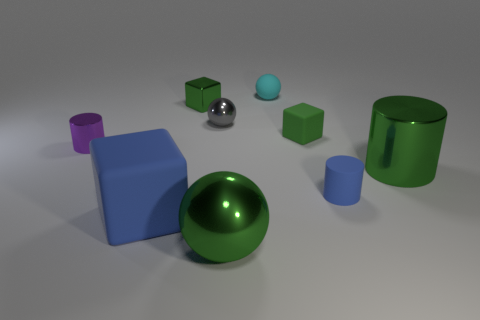Subtract all large green spheres. How many spheres are left? 2 Add 1 metallic cylinders. How many objects exist? 10 Subtract all cyan spheres. How many spheres are left? 2 Subtract all cylinders. How many objects are left? 6 Subtract 3 balls. How many balls are left? 0 Subtract all red cylinders. Subtract all yellow balls. How many cylinders are left? 3 Subtract all cyan cubes. How many purple spheres are left? 0 Subtract all blue cylinders. Subtract all small cylinders. How many objects are left? 6 Add 2 tiny cyan things. How many tiny cyan things are left? 3 Add 7 green matte cubes. How many green matte cubes exist? 8 